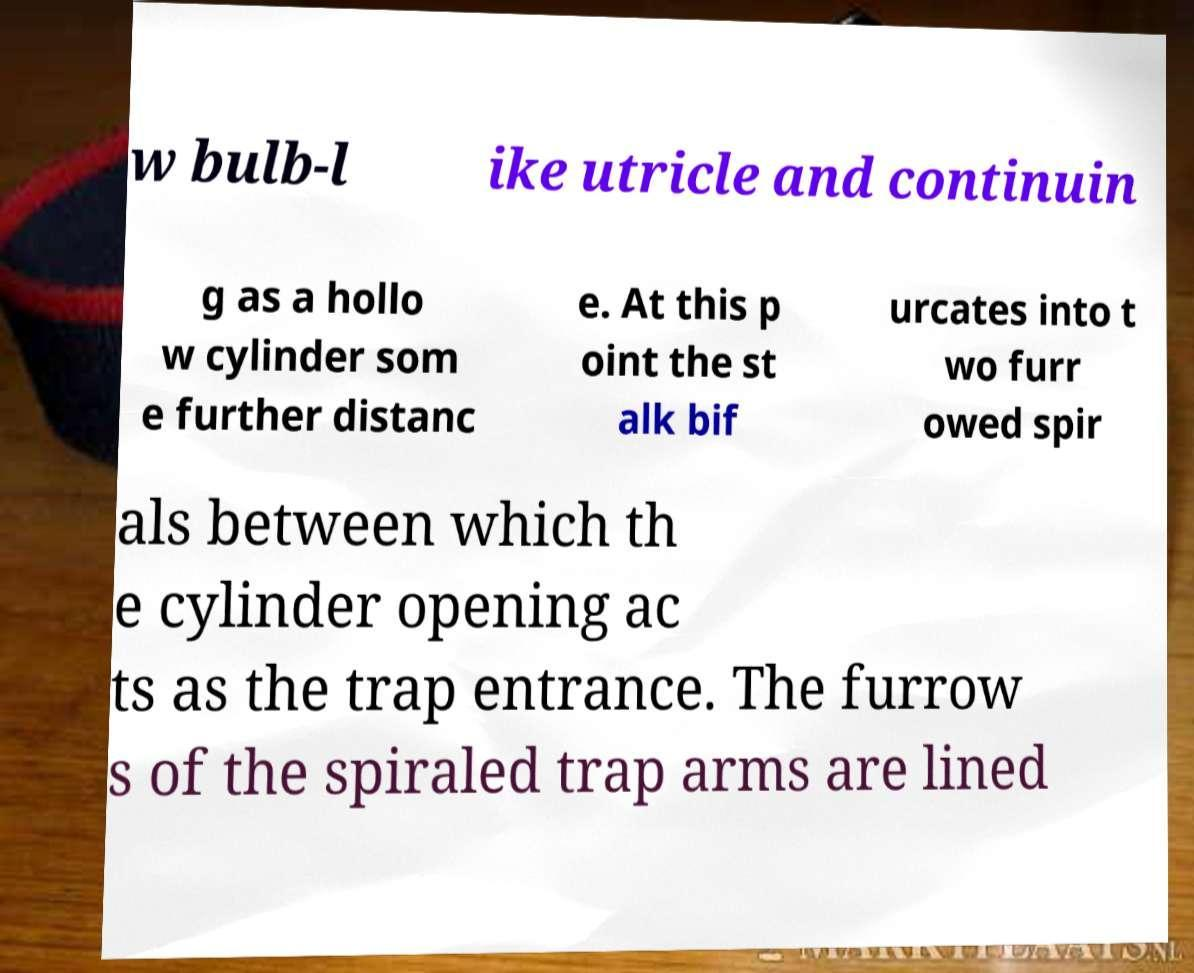For documentation purposes, I need the text within this image transcribed. Could you provide that? w bulb-l ike utricle and continuin g as a hollo w cylinder som e further distanc e. At this p oint the st alk bif urcates into t wo furr owed spir als between which th e cylinder opening ac ts as the trap entrance. The furrow s of the spiraled trap arms are lined 